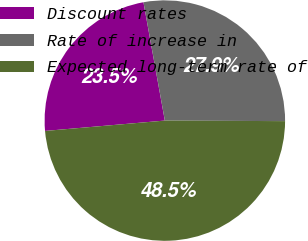Convert chart to OTSL. <chart><loc_0><loc_0><loc_500><loc_500><pie_chart><fcel>Discount rates<fcel>Rate of increase in<fcel>Expected long-term rate of<nl><fcel>23.53%<fcel>27.92%<fcel>48.55%<nl></chart> 